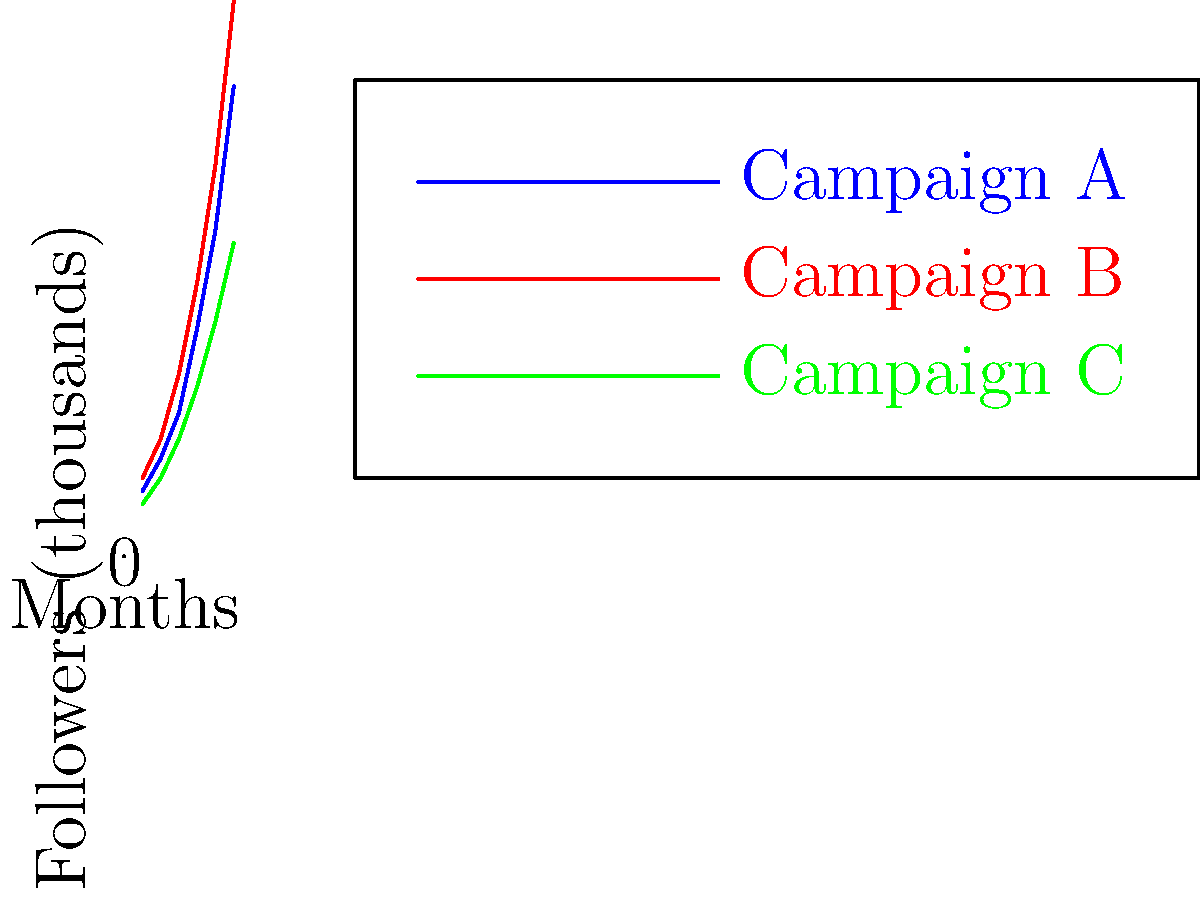As a prominent public figure advocating for social justice, you're analyzing the growth of social media followers for three different advocacy campaigns over a six-month period. Based on the line graph, which campaign shows the most consistent rate of growth, and how might this information be used to enhance future advocacy efforts? To determine the most consistent rate of growth, we need to analyze the slope of each line:

1. Examine Campaign A (blue line):
   - Shows an increasing slope, indicating accelerating growth.
   - Growth rate increases more rapidly in later months.

2. Examine Campaign B (red line):
   - Similar to Campaign A, but with a steeper overall slope.
   - Also shows accelerating growth, especially in later months.

3. Examine Campaign C (green line):
   - The slope appears relatively constant throughout the six months.
   - Growth rate is slower but more consistent compared to A and B.

Campaign C shows the most consistent rate of growth, as its line is the most straight, indicating a steady increase in followers over time.

Using this information for future advocacy efforts:

1. Understand growth patterns: Recognize that different campaigns may have different growth trajectories.
2. Set realistic expectations: Use Campaign C's consistent growth as a benchmark for steady progress.
3. Analyze successful strategies: Investigate what factors contributed to the rapid growth of Campaigns A and B in later months.
4. Tailor approach: Consider using a mix of steady (like C) and accelerating (like A and B) strategies for different campaign goals.
5. Resource allocation: Plan resources based on expected growth patterns, allocating more as campaigns gain momentum.
6. Engagement strategies: Develop strategies to maintain consistent growth while also preparing for potential rapid expansion periods.

By understanding these growth patterns, you can optimize future campaigns for both steady progress and potential viral moments, ultimately maximizing the impact of your advocacy efforts.
Answer: Campaign C; use as benchmark for steady growth, analyze A and B for rapid growth strategies, tailor approaches accordingly. 